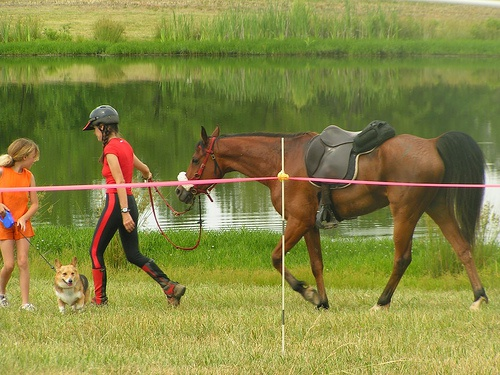Describe the objects in this image and their specific colors. I can see horse in tan, olive, maroon, black, and brown tones, people in tan, black, red, and darkgreen tones, people in tan, red, and brown tones, and dog in tan and olive tones in this image. 